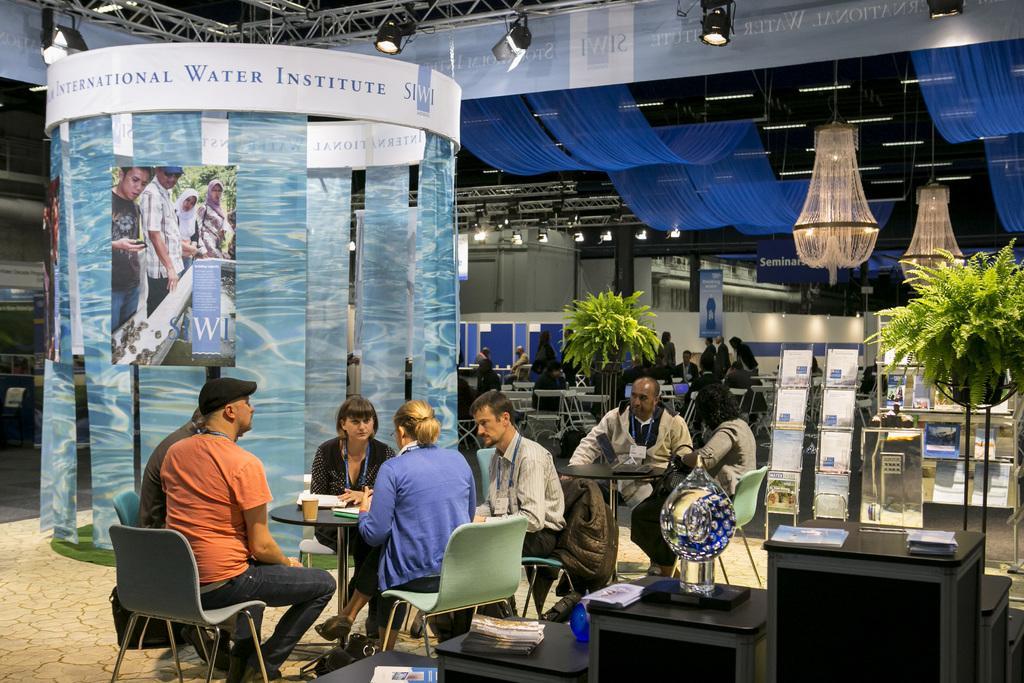Could you give a brief overview of what you see in this image? There are some people sitting in the chairs around the tables in this picture. There are some things placed on the table here. In the background there are some plants, chandelier and a wall here. 